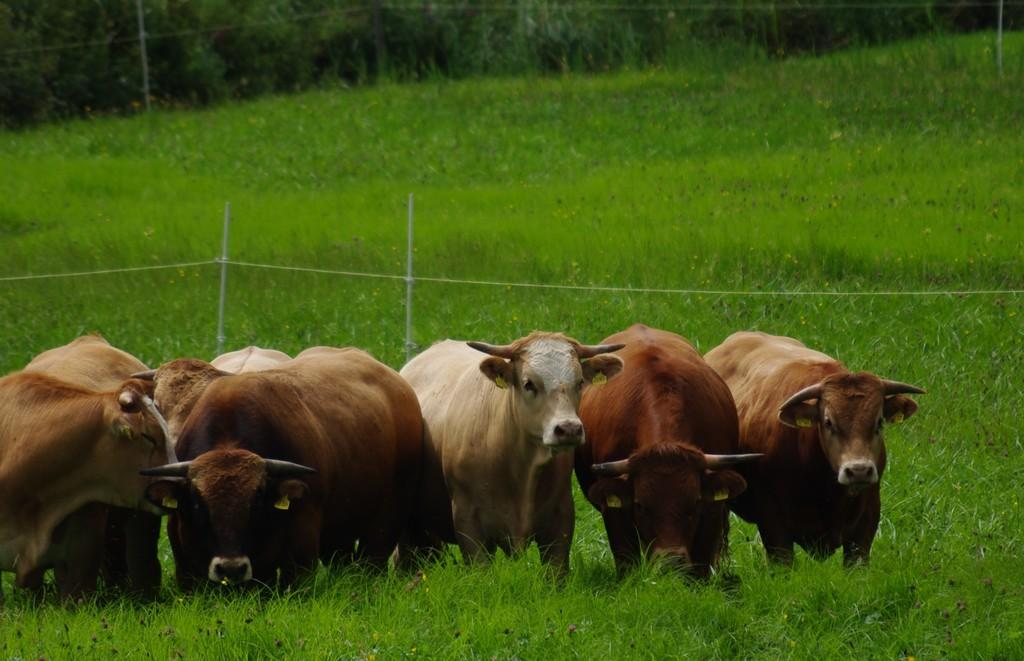What type of living organisms are present in the image? There are animals in the image. What is the surface on which the animals are standing? The animals are standing on the grass. What colors can be observed in the animals' fur? The animals are in brown and cream color. What objects can be seen in the background of the image? There is a rope and sticks visible in the background of the image. What type of natural environment is visible in the background? There are many trees in the background of the image. What type of root is being rewarded for its hard work in the image? There is no root or work being rewarded in the image; it features animals standing on grass with a background of trees, rope, and sticks. 